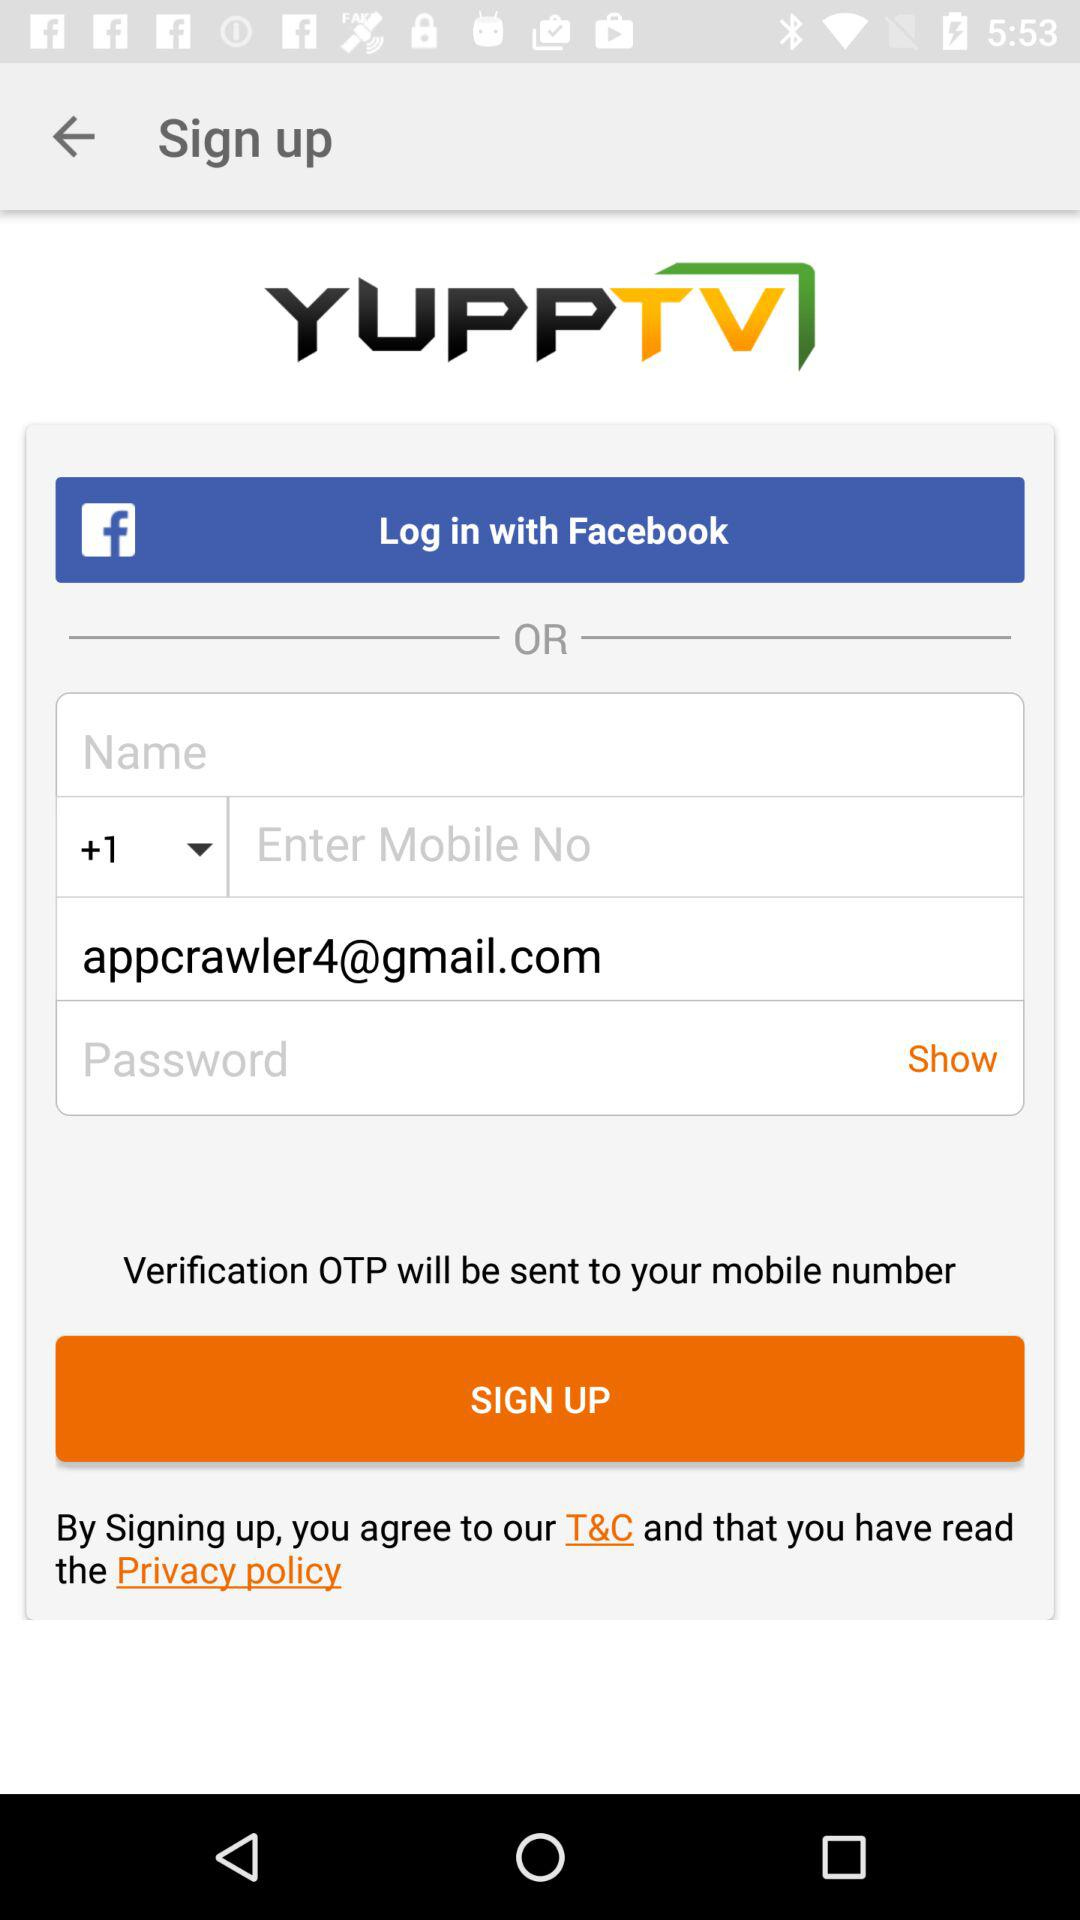What is the email address of the user? The email address is appcrawler4@gmail.com. 